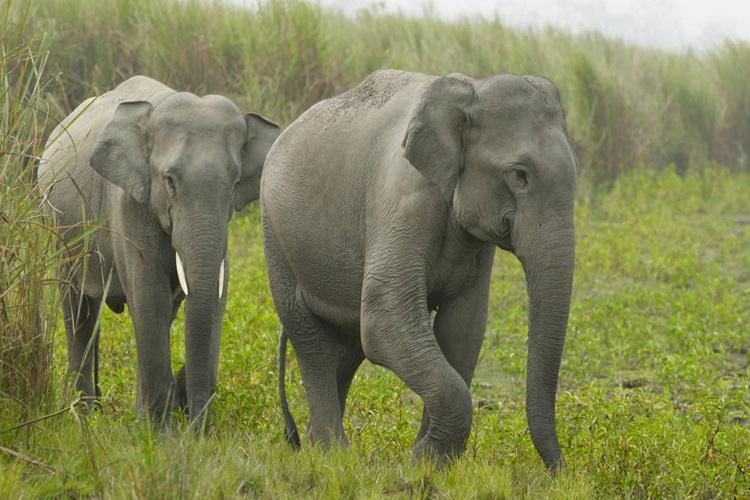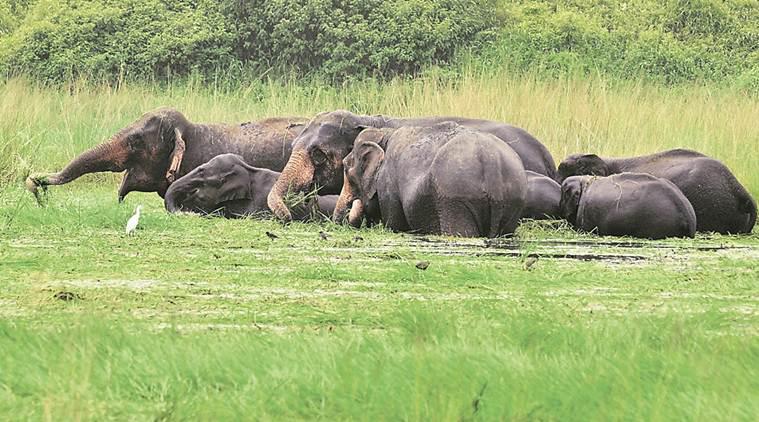The first image is the image on the left, the second image is the image on the right. For the images displayed, is the sentence "One image shows at least one elephant standing in a wet area." factually correct? Answer yes or no. Yes. 